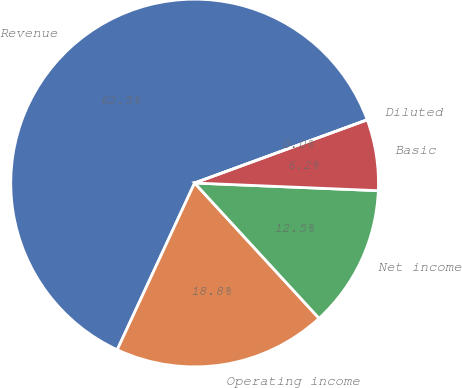Convert chart to OTSL. <chart><loc_0><loc_0><loc_500><loc_500><pie_chart><fcel>Revenue<fcel>Operating income<fcel>Net income<fcel>Basic<fcel>Diluted<nl><fcel>62.5%<fcel>18.75%<fcel>12.5%<fcel>6.25%<fcel>0.0%<nl></chart> 